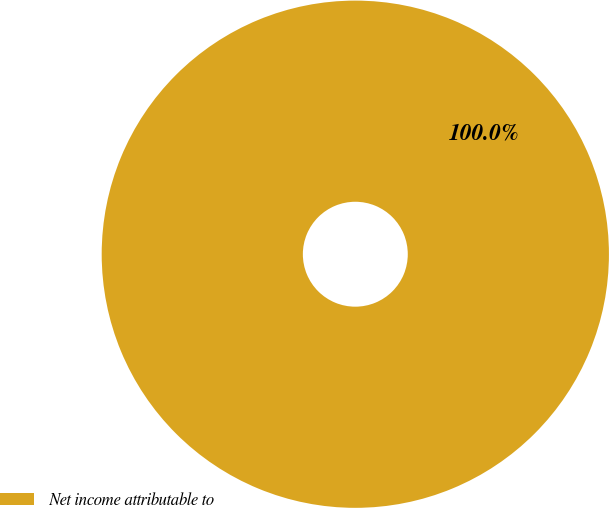Convert chart to OTSL. <chart><loc_0><loc_0><loc_500><loc_500><pie_chart><fcel>Net income attributable to<nl><fcel>100.0%<nl></chart> 